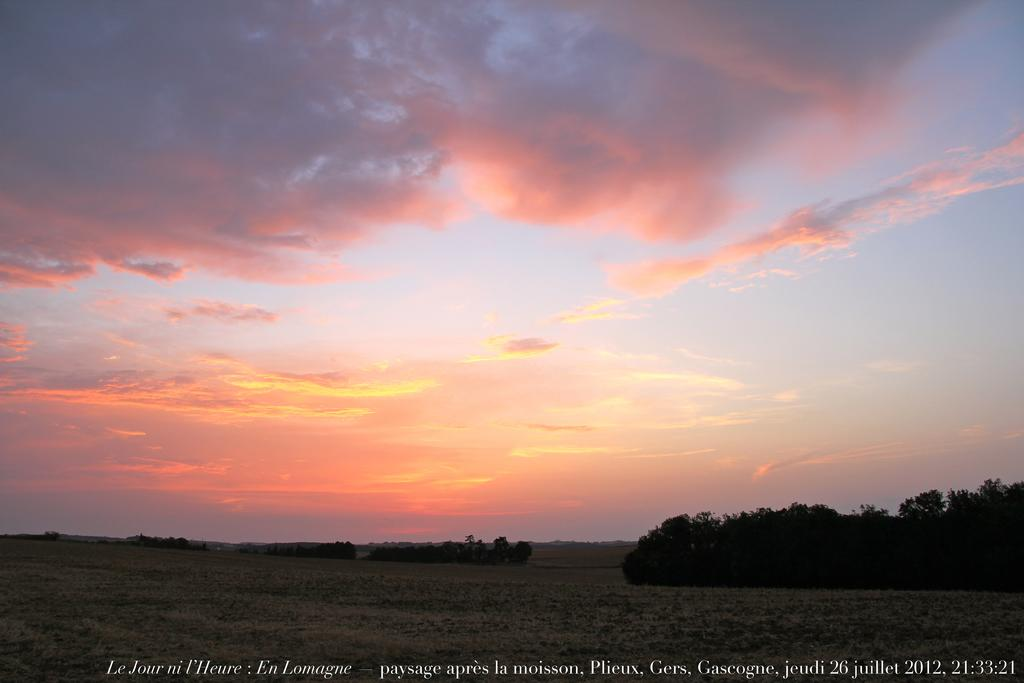What type of vegetation or plants can be seen at the bottom side of the image? There is greenery at the bottom side of the image. What part of the natural environment is visible at the top side of the image? The sky is visible at the top side of the image. What type of powder can be seen falling from the sky in the image? There is no powder falling from the sky in the image; only greenery and sky are visible. Can you see a ball being played with in the greenery at the bottom side of the image? There is no ball visible in the greenery at the bottom side of the image. 